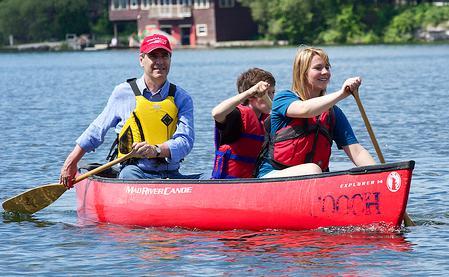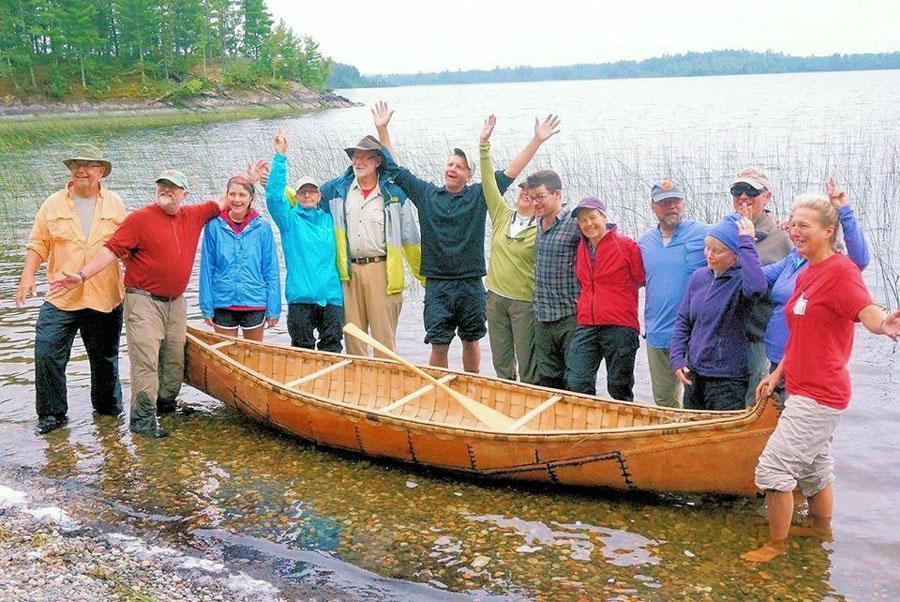The first image is the image on the left, the second image is the image on the right. Considering the images on both sides, is "One image shows people standing along one side of a canoe instead of sitting in it." valid? Answer yes or no. Yes. The first image is the image on the left, the second image is the image on the right. For the images shown, is this caption "In at least one of the images, people are shown outside of the canoe." true? Answer yes or no. Yes. 